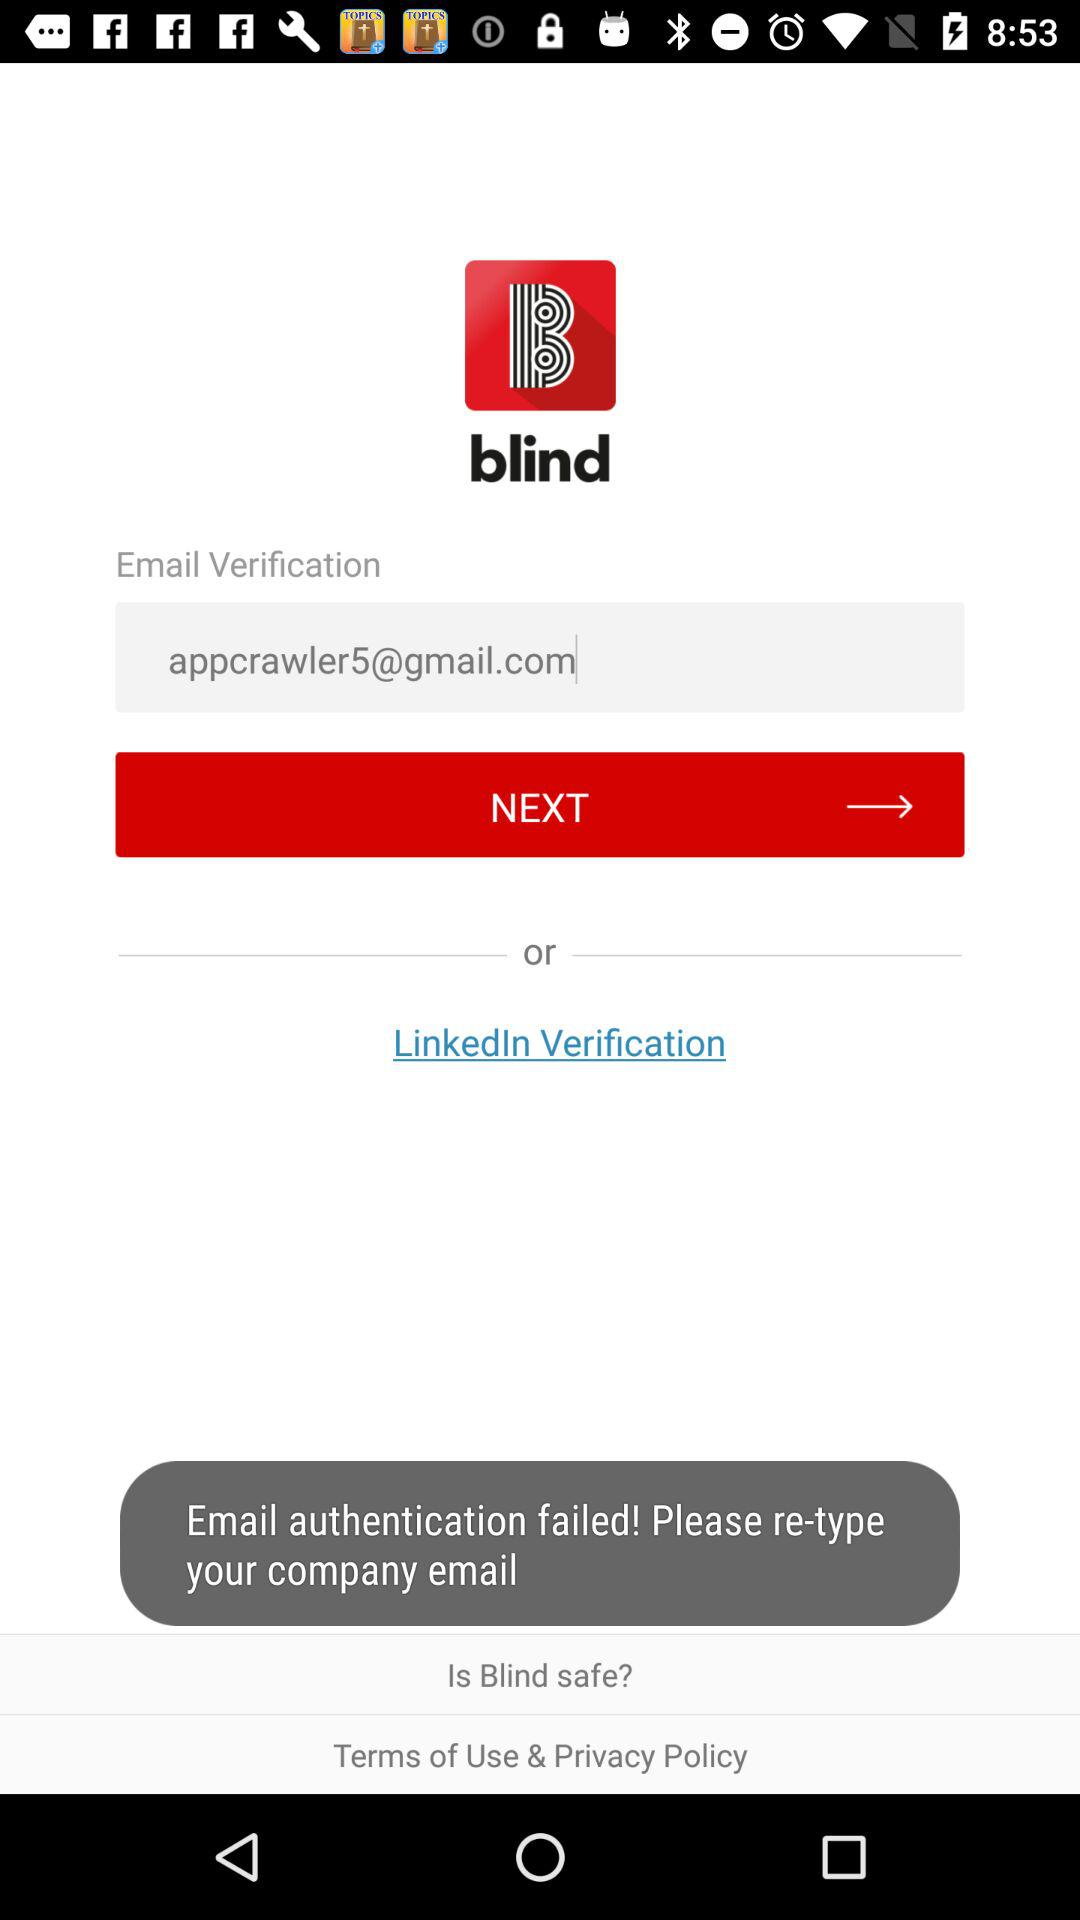How many text input fields are there on this page?
Answer the question using a single word or phrase. 1 